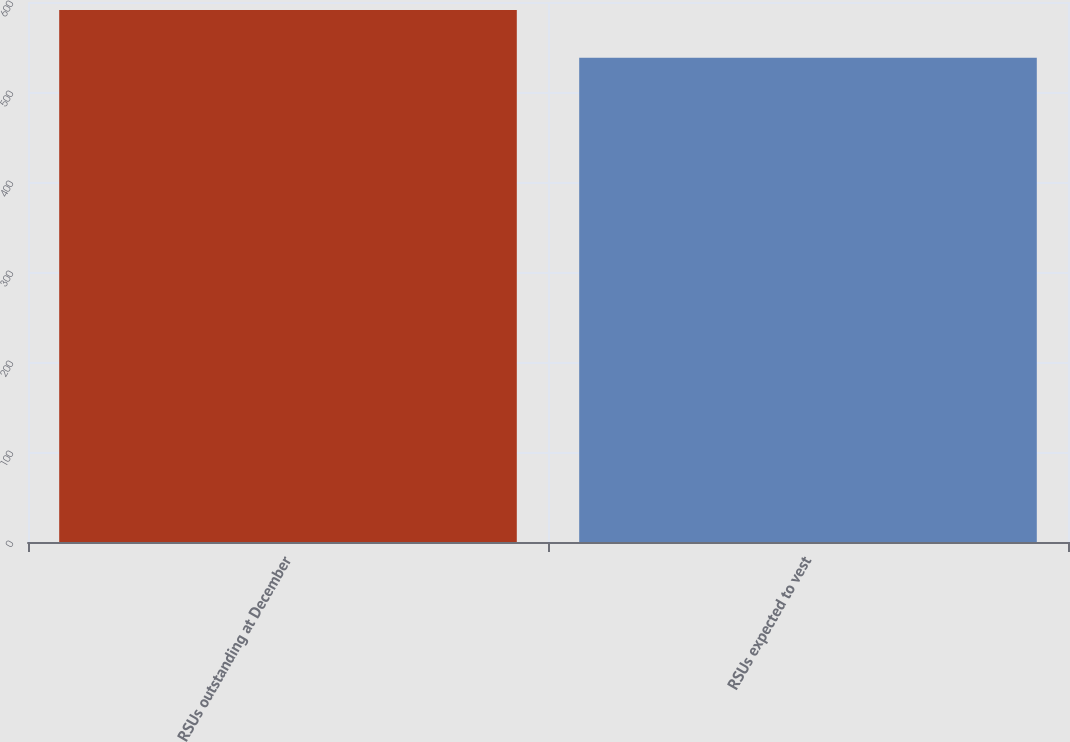Convert chart to OTSL. <chart><loc_0><loc_0><loc_500><loc_500><bar_chart><fcel>RSUs outstanding at December<fcel>RSUs expected to vest<nl><fcel>591<fcel>538<nl></chart> 